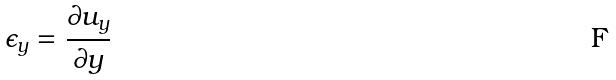<formula> <loc_0><loc_0><loc_500><loc_500>\epsilon _ { y } = \frac { \partial u _ { y } } { \partial y }</formula> 